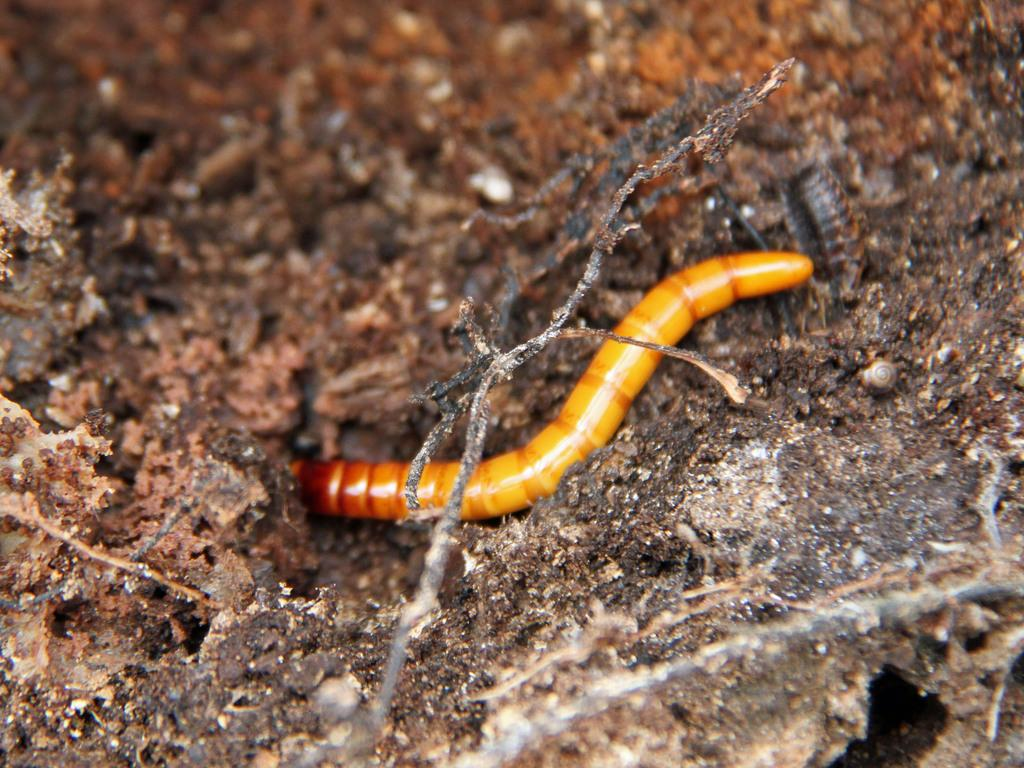What type of animal can be seen in the image? There is a worm in the ground in the image. Where is the worm located in the image? The worm is in the ground in the image. What type of cub can be seen playing with a yam in the image? There is no cub or yam present in the image; it features a worm in the ground. What discovery was made by the worm in the image? There is no indication of a discovery made by the worm in the image. 